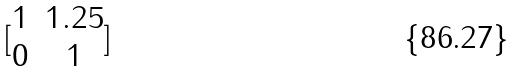<formula> <loc_0><loc_0><loc_500><loc_500>[ \begin{matrix} 1 & 1 . 2 5 \\ 0 & 1 \end{matrix} ]</formula> 